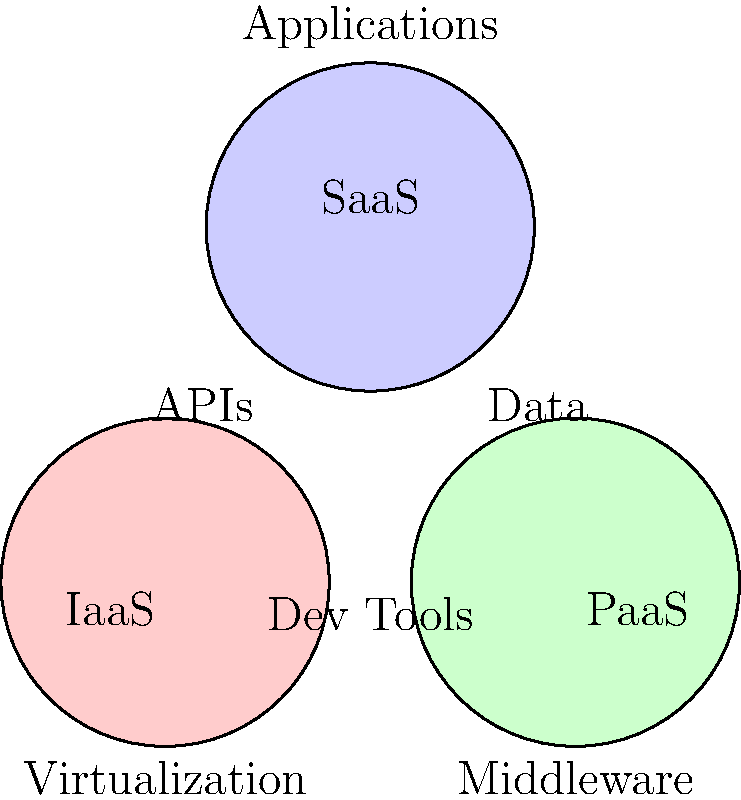As a software engineer developing cloud-based infrastructure solutions, analyze the Venn diagram representing different cloud service models (IaaS, PaaS, and SaaS). Which component is shared by all three service models and is crucial for integrating various services and applications in cloud computing? To answer this question, let's break down the Venn diagram and analyze the components shared by the different cloud service models:

1. IaaS (Infrastructure as a Service): Represented by the red circle on the left.
2. PaaS (Platform as a Service): Represented by the green circle on the right.
3. SaaS (Software as a Service): Represented by the blue circle on the top.

The components shown in the diagram are:
- Virtualization (specific to IaaS)
- Middleware (specific to PaaS)
- Applications (specific to SaaS)
- Dev Tools (shared by IaaS and PaaS)
- APIs (shared by all three models)
- Data (shared by PaaS and SaaS)

Among these components, only one is positioned at the intersection of all three circles: APIs (Application Programming Interfaces).

APIs are crucial for integrating various services and applications in cloud computing because they:
1. Enable communication between different software components and services.
2. Allow developers to access and utilize cloud resources and services across different models.
3. Facilitate the integration of different cloud services, regardless of the service model.
4. Provide a standardized way for applications to interact with cloud infrastructure, platforms, and software.

As a software engineer developing cloud-based infrastructure solutions, understanding the role of APIs in connecting different cloud service models is essential for creating integrated and efficient cloud solutions.
Answer: APIs (Application Programming Interfaces) 